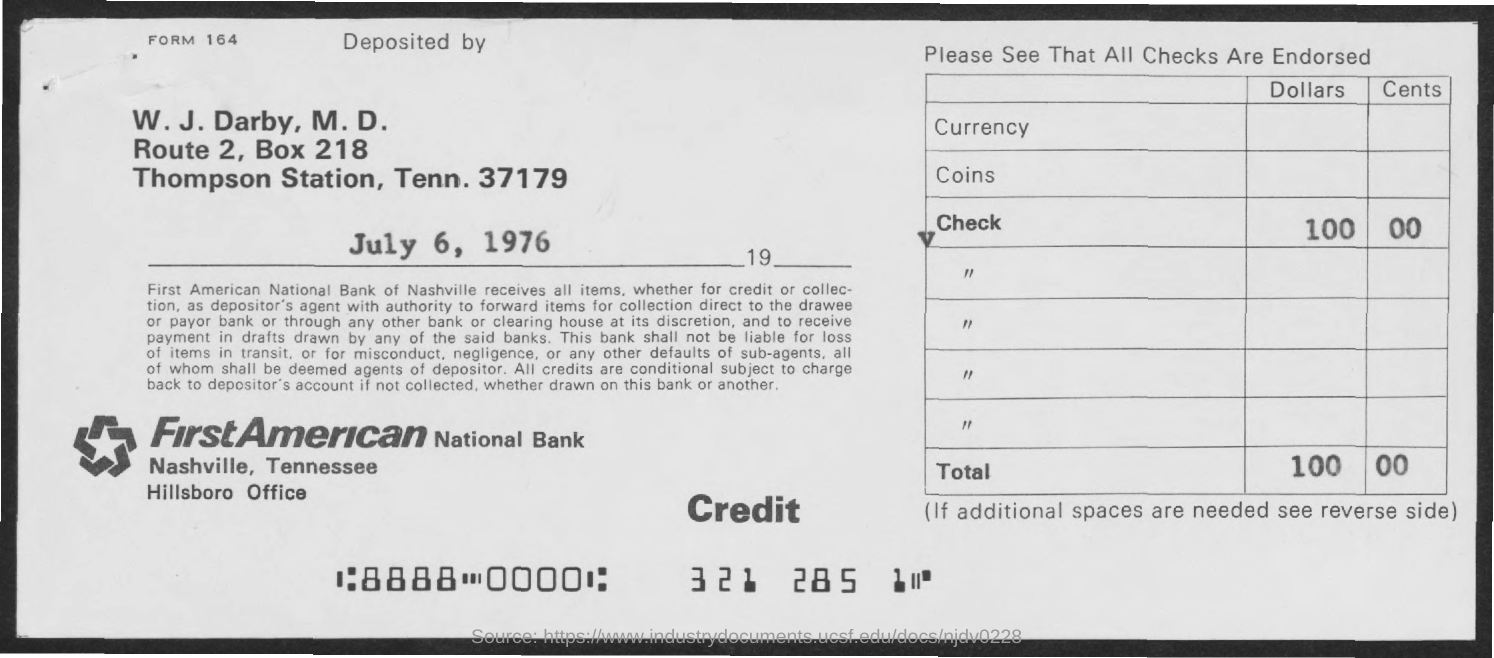Outline some significant characteristics in this image. The deposit date mentioned in the form is July 6, 1976. W. J. Darby, M.D., has deposited the check amount. 